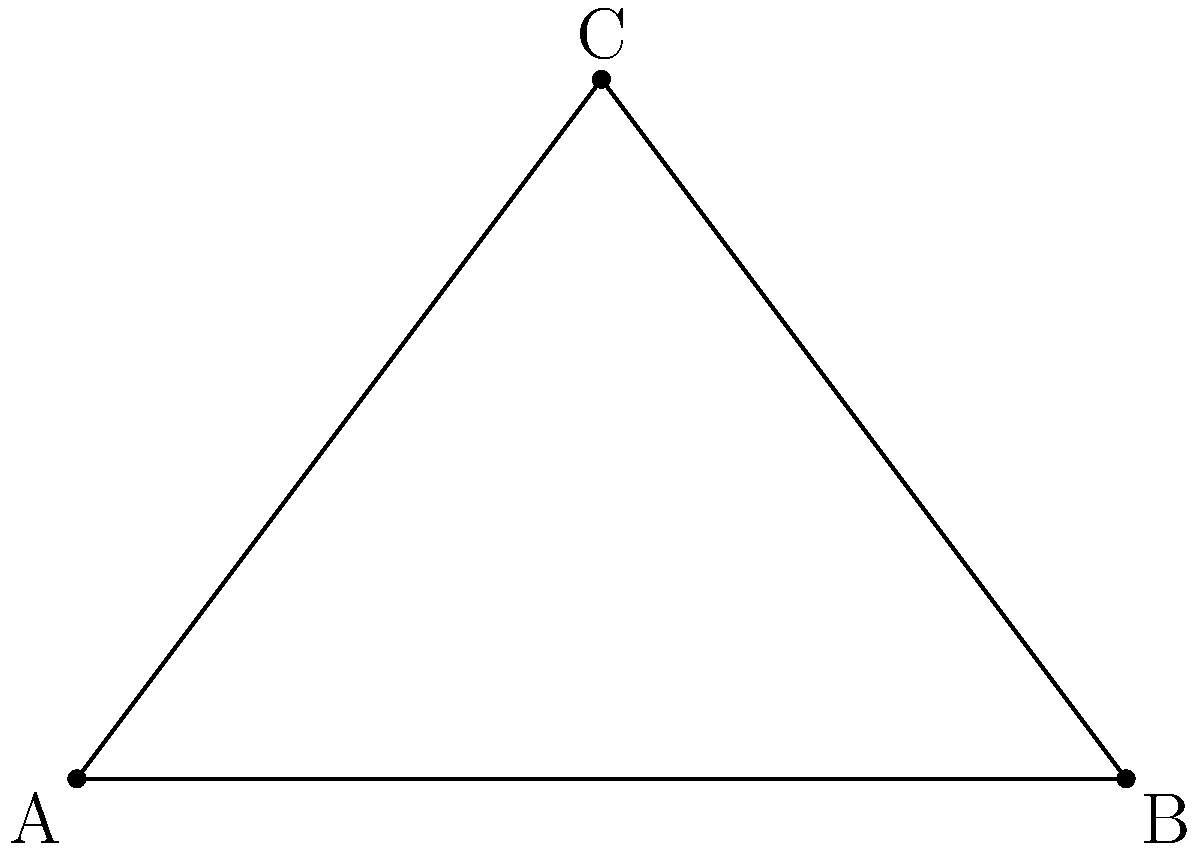At a car collision scene, you've measured the skid marks and determined that they form a right triangle. The angle of impact is represented by $x°$ in the diagram. If the angle between the road and the initial skid mark is $30°$, what is the value of $x°$? Let's approach this step-by-step:

1) In a right triangle, the sum of all angles is 180°.

2) We know one angle is 90° (the right angle), and another is 30°.

3) Let's set up an equation:
   $90° + 30° + x° = 180°$

4) Simplify:
   $120° + x° = 180°$

5) Subtract 120° from both sides:
   $x° = 180° - 120°$

6) Solve for $x$:
   $x° = 60°$

Therefore, the angle of impact ($x°$) is 60°.
Answer: 60° 